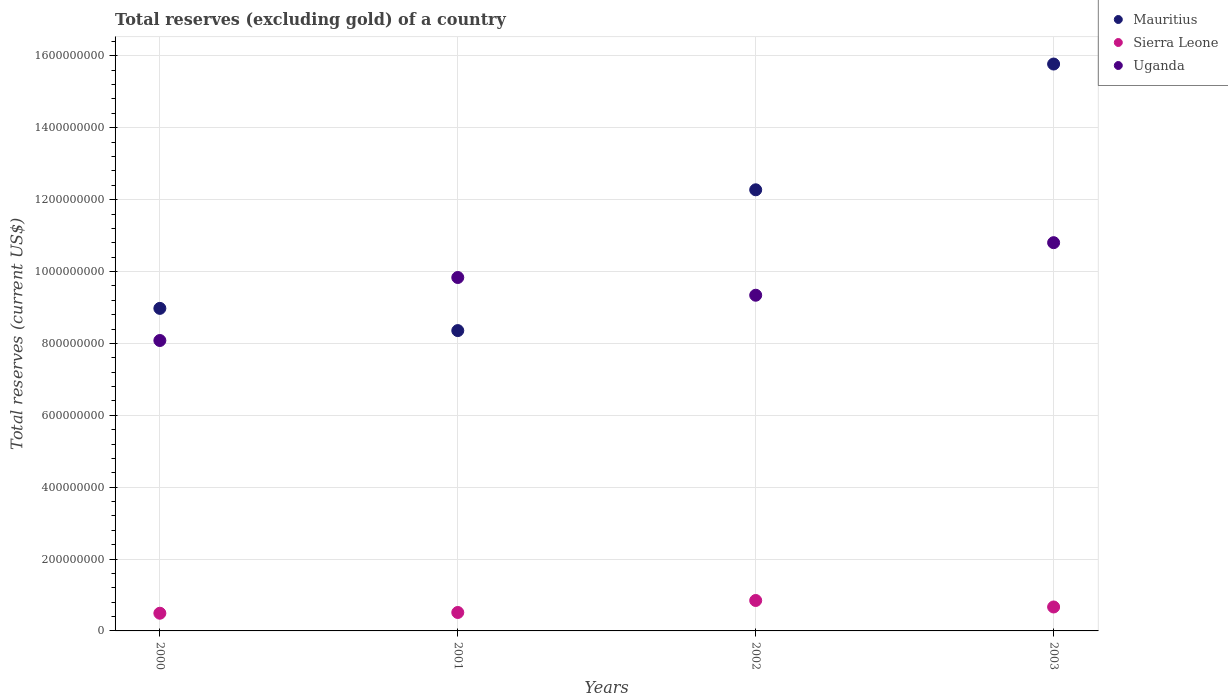What is the total reserves (excluding gold) in Uganda in 2002?
Provide a succinct answer. 9.34e+08. Across all years, what is the maximum total reserves (excluding gold) in Uganda?
Your response must be concise. 1.08e+09. Across all years, what is the minimum total reserves (excluding gold) in Sierra Leone?
Provide a succinct answer. 4.92e+07. In which year was the total reserves (excluding gold) in Sierra Leone maximum?
Provide a short and direct response. 2002. In which year was the total reserves (excluding gold) in Uganda minimum?
Give a very brief answer. 2000. What is the total total reserves (excluding gold) in Uganda in the graph?
Your response must be concise. 3.81e+09. What is the difference between the total reserves (excluding gold) in Uganda in 2001 and that in 2002?
Make the answer very short. 4.93e+07. What is the difference between the total reserves (excluding gold) in Mauritius in 2001 and the total reserves (excluding gold) in Sierra Leone in 2000?
Your response must be concise. 7.86e+08. What is the average total reserves (excluding gold) in Sierra Leone per year?
Offer a terse response. 6.30e+07. In the year 2001, what is the difference between the total reserves (excluding gold) in Mauritius and total reserves (excluding gold) in Uganda?
Provide a succinct answer. -1.48e+08. In how many years, is the total reserves (excluding gold) in Mauritius greater than 680000000 US$?
Give a very brief answer. 4. What is the ratio of the total reserves (excluding gold) in Uganda in 2000 to that in 2001?
Keep it short and to the point. 0.82. Is the total reserves (excluding gold) in Uganda in 2000 less than that in 2001?
Keep it short and to the point. Yes. What is the difference between the highest and the second highest total reserves (excluding gold) in Mauritius?
Ensure brevity in your answer.  3.50e+08. What is the difference between the highest and the lowest total reserves (excluding gold) in Mauritius?
Provide a succinct answer. 7.42e+08. In how many years, is the total reserves (excluding gold) in Mauritius greater than the average total reserves (excluding gold) in Mauritius taken over all years?
Offer a terse response. 2. Is it the case that in every year, the sum of the total reserves (excluding gold) in Uganda and total reserves (excluding gold) in Mauritius  is greater than the total reserves (excluding gold) in Sierra Leone?
Your answer should be very brief. Yes. Is the total reserves (excluding gold) in Sierra Leone strictly less than the total reserves (excluding gold) in Mauritius over the years?
Offer a very short reply. Yes. How many years are there in the graph?
Your response must be concise. 4. What is the difference between two consecutive major ticks on the Y-axis?
Make the answer very short. 2.00e+08. Where does the legend appear in the graph?
Your answer should be very brief. Top right. How are the legend labels stacked?
Your answer should be compact. Vertical. What is the title of the graph?
Offer a terse response. Total reserves (excluding gold) of a country. What is the label or title of the Y-axis?
Ensure brevity in your answer.  Total reserves (current US$). What is the Total reserves (current US$) of Mauritius in 2000?
Provide a short and direct response. 8.97e+08. What is the Total reserves (current US$) of Sierra Leone in 2000?
Provide a short and direct response. 4.92e+07. What is the Total reserves (current US$) of Uganda in 2000?
Provide a short and direct response. 8.08e+08. What is the Total reserves (current US$) of Mauritius in 2001?
Provide a succinct answer. 8.36e+08. What is the Total reserves (current US$) in Sierra Leone in 2001?
Your answer should be compact. 5.13e+07. What is the Total reserves (current US$) in Uganda in 2001?
Provide a succinct answer. 9.83e+08. What is the Total reserves (current US$) in Mauritius in 2002?
Provide a short and direct response. 1.23e+09. What is the Total reserves (current US$) in Sierra Leone in 2002?
Make the answer very short. 8.47e+07. What is the Total reserves (current US$) in Uganda in 2002?
Offer a terse response. 9.34e+08. What is the Total reserves (current US$) in Mauritius in 2003?
Ensure brevity in your answer.  1.58e+09. What is the Total reserves (current US$) of Sierra Leone in 2003?
Your response must be concise. 6.66e+07. What is the Total reserves (current US$) in Uganda in 2003?
Your answer should be compact. 1.08e+09. Across all years, what is the maximum Total reserves (current US$) of Mauritius?
Offer a terse response. 1.58e+09. Across all years, what is the maximum Total reserves (current US$) of Sierra Leone?
Make the answer very short. 8.47e+07. Across all years, what is the maximum Total reserves (current US$) of Uganda?
Your response must be concise. 1.08e+09. Across all years, what is the minimum Total reserves (current US$) of Mauritius?
Provide a succinct answer. 8.36e+08. Across all years, what is the minimum Total reserves (current US$) of Sierra Leone?
Make the answer very short. 4.92e+07. Across all years, what is the minimum Total reserves (current US$) of Uganda?
Keep it short and to the point. 8.08e+08. What is the total Total reserves (current US$) in Mauritius in the graph?
Your answer should be compact. 4.54e+09. What is the total Total reserves (current US$) of Sierra Leone in the graph?
Your answer should be compact. 2.52e+08. What is the total Total reserves (current US$) of Uganda in the graph?
Provide a succinct answer. 3.81e+09. What is the difference between the Total reserves (current US$) of Mauritius in 2000 and that in 2001?
Your response must be concise. 6.18e+07. What is the difference between the Total reserves (current US$) in Sierra Leone in 2000 and that in 2001?
Give a very brief answer. -2.10e+06. What is the difference between the Total reserves (current US$) in Uganda in 2000 and that in 2001?
Make the answer very short. -1.75e+08. What is the difference between the Total reserves (current US$) of Mauritius in 2000 and that in 2002?
Your answer should be compact. -3.30e+08. What is the difference between the Total reserves (current US$) of Sierra Leone in 2000 and that in 2002?
Your answer should be compact. -3.55e+07. What is the difference between the Total reserves (current US$) of Uganda in 2000 and that in 2002?
Make the answer very short. -1.26e+08. What is the difference between the Total reserves (current US$) in Mauritius in 2000 and that in 2003?
Offer a very short reply. -6.80e+08. What is the difference between the Total reserves (current US$) in Sierra Leone in 2000 and that in 2003?
Ensure brevity in your answer.  -1.74e+07. What is the difference between the Total reserves (current US$) of Uganda in 2000 and that in 2003?
Offer a terse response. -2.72e+08. What is the difference between the Total reserves (current US$) in Mauritius in 2001 and that in 2002?
Offer a very short reply. -3.92e+08. What is the difference between the Total reserves (current US$) of Sierra Leone in 2001 and that in 2002?
Your answer should be very brief. -3.34e+07. What is the difference between the Total reserves (current US$) in Uganda in 2001 and that in 2002?
Give a very brief answer. 4.93e+07. What is the difference between the Total reserves (current US$) in Mauritius in 2001 and that in 2003?
Your answer should be very brief. -7.42e+08. What is the difference between the Total reserves (current US$) in Sierra Leone in 2001 and that in 2003?
Your answer should be compact. -1.53e+07. What is the difference between the Total reserves (current US$) in Uganda in 2001 and that in 2003?
Give a very brief answer. -9.69e+07. What is the difference between the Total reserves (current US$) in Mauritius in 2002 and that in 2003?
Your answer should be compact. -3.50e+08. What is the difference between the Total reserves (current US$) of Sierra Leone in 2002 and that in 2003?
Provide a succinct answer. 1.81e+07. What is the difference between the Total reserves (current US$) in Uganda in 2002 and that in 2003?
Offer a very short reply. -1.46e+08. What is the difference between the Total reserves (current US$) in Mauritius in 2000 and the Total reserves (current US$) in Sierra Leone in 2001?
Your answer should be very brief. 8.46e+08. What is the difference between the Total reserves (current US$) of Mauritius in 2000 and the Total reserves (current US$) of Uganda in 2001?
Make the answer very short. -8.59e+07. What is the difference between the Total reserves (current US$) in Sierra Leone in 2000 and the Total reserves (current US$) in Uganda in 2001?
Provide a short and direct response. -9.34e+08. What is the difference between the Total reserves (current US$) of Mauritius in 2000 and the Total reserves (current US$) of Sierra Leone in 2002?
Offer a terse response. 8.13e+08. What is the difference between the Total reserves (current US$) in Mauritius in 2000 and the Total reserves (current US$) in Uganda in 2002?
Your answer should be very brief. -3.66e+07. What is the difference between the Total reserves (current US$) in Sierra Leone in 2000 and the Total reserves (current US$) in Uganda in 2002?
Your answer should be compact. -8.85e+08. What is the difference between the Total reserves (current US$) of Mauritius in 2000 and the Total reserves (current US$) of Sierra Leone in 2003?
Keep it short and to the point. 8.31e+08. What is the difference between the Total reserves (current US$) in Mauritius in 2000 and the Total reserves (current US$) in Uganda in 2003?
Make the answer very short. -1.83e+08. What is the difference between the Total reserves (current US$) in Sierra Leone in 2000 and the Total reserves (current US$) in Uganda in 2003?
Provide a short and direct response. -1.03e+09. What is the difference between the Total reserves (current US$) in Mauritius in 2001 and the Total reserves (current US$) in Sierra Leone in 2002?
Keep it short and to the point. 7.51e+08. What is the difference between the Total reserves (current US$) of Mauritius in 2001 and the Total reserves (current US$) of Uganda in 2002?
Your answer should be very brief. -9.84e+07. What is the difference between the Total reserves (current US$) in Sierra Leone in 2001 and the Total reserves (current US$) in Uganda in 2002?
Your answer should be compact. -8.83e+08. What is the difference between the Total reserves (current US$) in Mauritius in 2001 and the Total reserves (current US$) in Sierra Leone in 2003?
Give a very brief answer. 7.69e+08. What is the difference between the Total reserves (current US$) in Mauritius in 2001 and the Total reserves (current US$) in Uganda in 2003?
Make the answer very short. -2.45e+08. What is the difference between the Total reserves (current US$) in Sierra Leone in 2001 and the Total reserves (current US$) in Uganda in 2003?
Provide a succinct answer. -1.03e+09. What is the difference between the Total reserves (current US$) in Mauritius in 2002 and the Total reserves (current US$) in Sierra Leone in 2003?
Provide a succinct answer. 1.16e+09. What is the difference between the Total reserves (current US$) in Mauritius in 2002 and the Total reserves (current US$) in Uganda in 2003?
Give a very brief answer. 1.47e+08. What is the difference between the Total reserves (current US$) in Sierra Leone in 2002 and the Total reserves (current US$) in Uganda in 2003?
Make the answer very short. -9.96e+08. What is the average Total reserves (current US$) of Mauritius per year?
Provide a succinct answer. 1.13e+09. What is the average Total reserves (current US$) in Sierra Leone per year?
Provide a short and direct response. 6.30e+07. What is the average Total reserves (current US$) in Uganda per year?
Your response must be concise. 9.51e+08. In the year 2000, what is the difference between the Total reserves (current US$) in Mauritius and Total reserves (current US$) in Sierra Leone?
Ensure brevity in your answer.  8.48e+08. In the year 2000, what is the difference between the Total reserves (current US$) in Mauritius and Total reserves (current US$) in Uganda?
Provide a short and direct response. 8.94e+07. In the year 2000, what is the difference between the Total reserves (current US$) in Sierra Leone and Total reserves (current US$) in Uganda?
Your response must be concise. -7.59e+08. In the year 2001, what is the difference between the Total reserves (current US$) in Mauritius and Total reserves (current US$) in Sierra Leone?
Give a very brief answer. 7.84e+08. In the year 2001, what is the difference between the Total reserves (current US$) in Mauritius and Total reserves (current US$) in Uganda?
Give a very brief answer. -1.48e+08. In the year 2001, what is the difference between the Total reserves (current US$) of Sierra Leone and Total reserves (current US$) of Uganda?
Ensure brevity in your answer.  -9.32e+08. In the year 2002, what is the difference between the Total reserves (current US$) of Mauritius and Total reserves (current US$) of Sierra Leone?
Provide a succinct answer. 1.14e+09. In the year 2002, what is the difference between the Total reserves (current US$) of Mauritius and Total reserves (current US$) of Uganda?
Make the answer very short. 2.93e+08. In the year 2002, what is the difference between the Total reserves (current US$) in Sierra Leone and Total reserves (current US$) in Uganda?
Ensure brevity in your answer.  -8.49e+08. In the year 2003, what is the difference between the Total reserves (current US$) in Mauritius and Total reserves (current US$) in Sierra Leone?
Your answer should be very brief. 1.51e+09. In the year 2003, what is the difference between the Total reserves (current US$) in Mauritius and Total reserves (current US$) in Uganda?
Your answer should be very brief. 4.97e+08. In the year 2003, what is the difference between the Total reserves (current US$) in Sierra Leone and Total reserves (current US$) in Uganda?
Provide a short and direct response. -1.01e+09. What is the ratio of the Total reserves (current US$) of Mauritius in 2000 to that in 2001?
Provide a succinct answer. 1.07. What is the ratio of the Total reserves (current US$) in Sierra Leone in 2000 to that in 2001?
Give a very brief answer. 0.96. What is the ratio of the Total reserves (current US$) of Uganda in 2000 to that in 2001?
Provide a short and direct response. 0.82. What is the ratio of the Total reserves (current US$) in Mauritius in 2000 to that in 2002?
Your answer should be compact. 0.73. What is the ratio of the Total reserves (current US$) of Sierra Leone in 2000 to that in 2002?
Provide a succinct answer. 0.58. What is the ratio of the Total reserves (current US$) in Uganda in 2000 to that in 2002?
Keep it short and to the point. 0.87. What is the ratio of the Total reserves (current US$) of Mauritius in 2000 to that in 2003?
Offer a very short reply. 0.57. What is the ratio of the Total reserves (current US$) in Sierra Leone in 2000 to that in 2003?
Provide a succinct answer. 0.74. What is the ratio of the Total reserves (current US$) of Uganda in 2000 to that in 2003?
Give a very brief answer. 0.75. What is the ratio of the Total reserves (current US$) of Mauritius in 2001 to that in 2002?
Keep it short and to the point. 0.68. What is the ratio of the Total reserves (current US$) of Sierra Leone in 2001 to that in 2002?
Your answer should be very brief. 0.61. What is the ratio of the Total reserves (current US$) of Uganda in 2001 to that in 2002?
Offer a very short reply. 1.05. What is the ratio of the Total reserves (current US$) of Mauritius in 2001 to that in 2003?
Make the answer very short. 0.53. What is the ratio of the Total reserves (current US$) of Sierra Leone in 2001 to that in 2003?
Your answer should be compact. 0.77. What is the ratio of the Total reserves (current US$) of Uganda in 2001 to that in 2003?
Give a very brief answer. 0.91. What is the ratio of the Total reserves (current US$) in Mauritius in 2002 to that in 2003?
Ensure brevity in your answer.  0.78. What is the ratio of the Total reserves (current US$) in Sierra Leone in 2002 to that in 2003?
Your answer should be very brief. 1.27. What is the ratio of the Total reserves (current US$) of Uganda in 2002 to that in 2003?
Keep it short and to the point. 0.86. What is the difference between the highest and the second highest Total reserves (current US$) of Mauritius?
Provide a short and direct response. 3.50e+08. What is the difference between the highest and the second highest Total reserves (current US$) of Sierra Leone?
Provide a short and direct response. 1.81e+07. What is the difference between the highest and the second highest Total reserves (current US$) of Uganda?
Give a very brief answer. 9.69e+07. What is the difference between the highest and the lowest Total reserves (current US$) in Mauritius?
Ensure brevity in your answer.  7.42e+08. What is the difference between the highest and the lowest Total reserves (current US$) of Sierra Leone?
Your response must be concise. 3.55e+07. What is the difference between the highest and the lowest Total reserves (current US$) in Uganda?
Make the answer very short. 2.72e+08. 